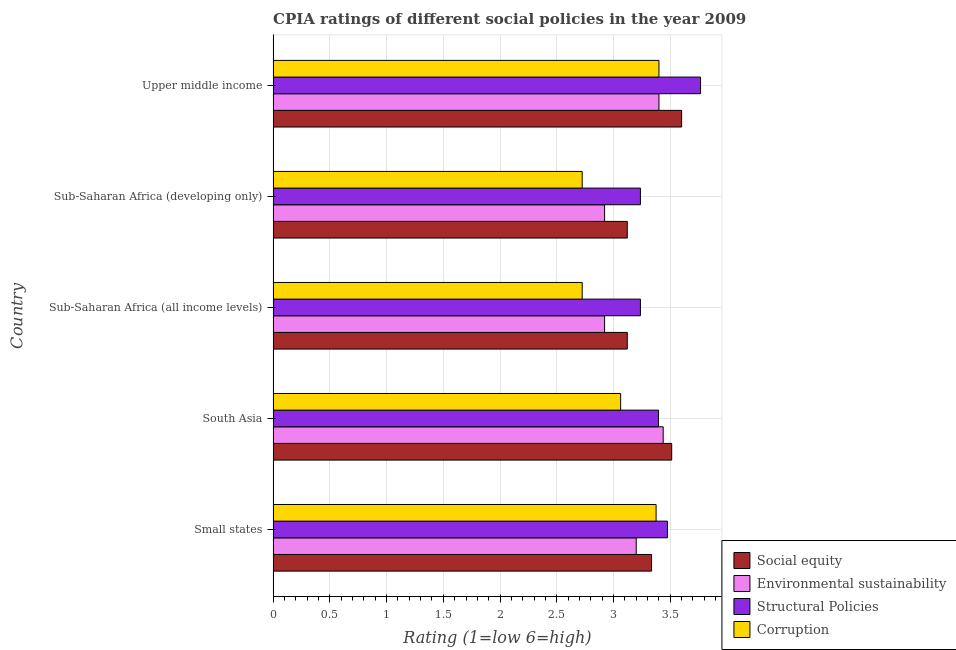How many different coloured bars are there?
Ensure brevity in your answer.  4. What is the label of the 2nd group of bars from the top?
Provide a short and direct response. Sub-Saharan Africa (developing only). In how many cases, is the number of bars for a given country not equal to the number of legend labels?
Provide a succinct answer. 0. Across all countries, what is the maximum cpia rating of social equity?
Offer a very short reply. 3.6. Across all countries, what is the minimum cpia rating of corruption?
Make the answer very short. 2.72. In which country was the cpia rating of social equity maximum?
Ensure brevity in your answer.  Upper middle income. In which country was the cpia rating of corruption minimum?
Your answer should be very brief. Sub-Saharan Africa (all income levels). What is the total cpia rating of structural policies in the graph?
Your response must be concise. 17.11. What is the difference between the cpia rating of structural policies in Small states and that in Upper middle income?
Your answer should be compact. -0.29. What is the difference between the cpia rating of structural policies in South Asia and the cpia rating of environmental sustainability in Upper middle income?
Offer a very short reply. -0. What is the average cpia rating of structural policies per country?
Offer a very short reply. 3.42. In how many countries, is the cpia rating of structural policies greater than 1.7 ?
Make the answer very short. 5. What is the ratio of the cpia rating of structural policies in Small states to that in Sub-Saharan Africa (all income levels)?
Make the answer very short. 1.07. Is the cpia rating of social equity in Sub-Saharan Africa (all income levels) less than that in Sub-Saharan Africa (developing only)?
Provide a short and direct response. No. What is the difference between the highest and the second highest cpia rating of social equity?
Give a very brief answer. 0.09. What is the difference between the highest and the lowest cpia rating of environmental sustainability?
Offer a very short reply. 0.52. In how many countries, is the cpia rating of environmental sustainability greater than the average cpia rating of environmental sustainability taken over all countries?
Your answer should be very brief. 3. What does the 3rd bar from the top in Upper middle income represents?
Your answer should be compact. Environmental sustainability. What does the 2nd bar from the bottom in Small states represents?
Make the answer very short. Environmental sustainability. Is it the case that in every country, the sum of the cpia rating of social equity and cpia rating of environmental sustainability is greater than the cpia rating of structural policies?
Your response must be concise. Yes. How many countries are there in the graph?
Make the answer very short. 5. Does the graph contain grids?
Make the answer very short. Yes. Where does the legend appear in the graph?
Your answer should be very brief. Bottom right. What is the title of the graph?
Offer a very short reply. CPIA ratings of different social policies in the year 2009. Does "Third 20% of population" appear as one of the legend labels in the graph?
Provide a succinct answer. No. What is the label or title of the X-axis?
Make the answer very short. Rating (1=low 6=high). What is the Rating (1=low 6=high) of Social equity in Small states?
Your answer should be compact. 3.33. What is the Rating (1=low 6=high) in Structural Policies in Small states?
Offer a very short reply. 3.48. What is the Rating (1=low 6=high) in Corruption in Small states?
Your answer should be compact. 3.38. What is the Rating (1=low 6=high) of Social equity in South Asia?
Offer a terse response. 3.51. What is the Rating (1=low 6=high) of Environmental sustainability in South Asia?
Provide a short and direct response. 3.44. What is the Rating (1=low 6=high) in Structural Policies in South Asia?
Keep it short and to the point. 3.4. What is the Rating (1=low 6=high) of Corruption in South Asia?
Your answer should be very brief. 3.06. What is the Rating (1=low 6=high) in Social equity in Sub-Saharan Africa (all income levels)?
Provide a short and direct response. 3.12. What is the Rating (1=low 6=high) of Environmental sustainability in Sub-Saharan Africa (all income levels)?
Your answer should be very brief. 2.92. What is the Rating (1=low 6=high) in Structural Policies in Sub-Saharan Africa (all income levels)?
Offer a very short reply. 3.24. What is the Rating (1=low 6=high) of Corruption in Sub-Saharan Africa (all income levels)?
Provide a short and direct response. 2.72. What is the Rating (1=low 6=high) of Social equity in Sub-Saharan Africa (developing only)?
Your answer should be compact. 3.12. What is the Rating (1=low 6=high) of Environmental sustainability in Sub-Saharan Africa (developing only)?
Give a very brief answer. 2.92. What is the Rating (1=low 6=high) in Structural Policies in Sub-Saharan Africa (developing only)?
Give a very brief answer. 3.24. What is the Rating (1=low 6=high) in Corruption in Sub-Saharan Africa (developing only)?
Ensure brevity in your answer.  2.72. What is the Rating (1=low 6=high) in Structural Policies in Upper middle income?
Your answer should be very brief. 3.77. Across all countries, what is the maximum Rating (1=low 6=high) of Environmental sustainability?
Your answer should be very brief. 3.44. Across all countries, what is the maximum Rating (1=low 6=high) in Structural Policies?
Offer a very short reply. 3.77. Across all countries, what is the maximum Rating (1=low 6=high) of Corruption?
Provide a short and direct response. 3.4. Across all countries, what is the minimum Rating (1=low 6=high) of Social equity?
Provide a short and direct response. 3.12. Across all countries, what is the minimum Rating (1=low 6=high) in Environmental sustainability?
Keep it short and to the point. 2.92. Across all countries, what is the minimum Rating (1=low 6=high) in Structural Policies?
Your answer should be very brief. 3.24. Across all countries, what is the minimum Rating (1=low 6=high) of Corruption?
Offer a terse response. 2.72. What is the total Rating (1=low 6=high) of Social equity in the graph?
Offer a very short reply. 16.69. What is the total Rating (1=low 6=high) in Environmental sustainability in the graph?
Keep it short and to the point. 15.88. What is the total Rating (1=low 6=high) of Structural Policies in the graph?
Your response must be concise. 17.11. What is the total Rating (1=low 6=high) in Corruption in the graph?
Offer a very short reply. 15.28. What is the difference between the Rating (1=low 6=high) in Social equity in Small states and that in South Asia?
Offer a very short reply. -0.18. What is the difference between the Rating (1=low 6=high) in Environmental sustainability in Small states and that in South Asia?
Your answer should be compact. -0.24. What is the difference between the Rating (1=low 6=high) in Structural Policies in Small states and that in South Asia?
Offer a very short reply. 0.08. What is the difference between the Rating (1=low 6=high) of Corruption in Small states and that in South Asia?
Make the answer very short. 0.31. What is the difference between the Rating (1=low 6=high) of Social equity in Small states and that in Sub-Saharan Africa (all income levels)?
Your response must be concise. 0.21. What is the difference between the Rating (1=low 6=high) in Environmental sustainability in Small states and that in Sub-Saharan Africa (all income levels)?
Your response must be concise. 0.28. What is the difference between the Rating (1=low 6=high) of Structural Policies in Small states and that in Sub-Saharan Africa (all income levels)?
Provide a short and direct response. 0.24. What is the difference between the Rating (1=low 6=high) of Corruption in Small states and that in Sub-Saharan Africa (all income levels)?
Your answer should be compact. 0.65. What is the difference between the Rating (1=low 6=high) of Social equity in Small states and that in Sub-Saharan Africa (developing only)?
Your answer should be very brief. 0.21. What is the difference between the Rating (1=low 6=high) in Environmental sustainability in Small states and that in Sub-Saharan Africa (developing only)?
Provide a short and direct response. 0.28. What is the difference between the Rating (1=low 6=high) in Structural Policies in Small states and that in Sub-Saharan Africa (developing only)?
Keep it short and to the point. 0.24. What is the difference between the Rating (1=low 6=high) in Corruption in Small states and that in Sub-Saharan Africa (developing only)?
Provide a short and direct response. 0.65. What is the difference between the Rating (1=low 6=high) of Social equity in Small states and that in Upper middle income?
Give a very brief answer. -0.27. What is the difference between the Rating (1=low 6=high) of Structural Policies in Small states and that in Upper middle income?
Provide a short and direct response. -0.29. What is the difference between the Rating (1=low 6=high) of Corruption in Small states and that in Upper middle income?
Your answer should be compact. -0.03. What is the difference between the Rating (1=low 6=high) in Social equity in South Asia and that in Sub-Saharan Africa (all income levels)?
Provide a short and direct response. 0.39. What is the difference between the Rating (1=low 6=high) in Environmental sustainability in South Asia and that in Sub-Saharan Africa (all income levels)?
Provide a succinct answer. 0.52. What is the difference between the Rating (1=low 6=high) of Structural Policies in South Asia and that in Sub-Saharan Africa (all income levels)?
Your answer should be very brief. 0.16. What is the difference between the Rating (1=low 6=high) in Corruption in South Asia and that in Sub-Saharan Africa (all income levels)?
Ensure brevity in your answer.  0.34. What is the difference between the Rating (1=low 6=high) of Social equity in South Asia and that in Sub-Saharan Africa (developing only)?
Offer a terse response. 0.39. What is the difference between the Rating (1=low 6=high) of Environmental sustainability in South Asia and that in Sub-Saharan Africa (developing only)?
Ensure brevity in your answer.  0.52. What is the difference between the Rating (1=low 6=high) of Structural Policies in South Asia and that in Sub-Saharan Africa (developing only)?
Offer a very short reply. 0.16. What is the difference between the Rating (1=low 6=high) of Corruption in South Asia and that in Sub-Saharan Africa (developing only)?
Your answer should be very brief. 0.34. What is the difference between the Rating (1=low 6=high) in Social equity in South Asia and that in Upper middle income?
Your answer should be very brief. -0.09. What is the difference between the Rating (1=low 6=high) of Environmental sustainability in South Asia and that in Upper middle income?
Your answer should be very brief. 0.04. What is the difference between the Rating (1=low 6=high) of Structural Policies in South Asia and that in Upper middle income?
Your answer should be compact. -0.37. What is the difference between the Rating (1=low 6=high) in Corruption in South Asia and that in Upper middle income?
Keep it short and to the point. -0.34. What is the difference between the Rating (1=low 6=high) in Environmental sustainability in Sub-Saharan Africa (all income levels) and that in Sub-Saharan Africa (developing only)?
Provide a short and direct response. 0. What is the difference between the Rating (1=low 6=high) of Structural Policies in Sub-Saharan Africa (all income levels) and that in Sub-Saharan Africa (developing only)?
Provide a succinct answer. 0. What is the difference between the Rating (1=low 6=high) of Social equity in Sub-Saharan Africa (all income levels) and that in Upper middle income?
Make the answer very short. -0.48. What is the difference between the Rating (1=low 6=high) in Environmental sustainability in Sub-Saharan Africa (all income levels) and that in Upper middle income?
Make the answer very short. -0.48. What is the difference between the Rating (1=low 6=high) of Structural Policies in Sub-Saharan Africa (all income levels) and that in Upper middle income?
Offer a terse response. -0.53. What is the difference between the Rating (1=low 6=high) of Corruption in Sub-Saharan Africa (all income levels) and that in Upper middle income?
Offer a very short reply. -0.68. What is the difference between the Rating (1=low 6=high) in Social equity in Sub-Saharan Africa (developing only) and that in Upper middle income?
Make the answer very short. -0.48. What is the difference between the Rating (1=low 6=high) of Environmental sustainability in Sub-Saharan Africa (developing only) and that in Upper middle income?
Your answer should be compact. -0.48. What is the difference between the Rating (1=low 6=high) in Structural Policies in Sub-Saharan Africa (developing only) and that in Upper middle income?
Ensure brevity in your answer.  -0.53. What is the difference between the Rating (1=low 6=high) in Corruption in Sub-Saharan Africa (developing only) and that in Upper middle income?
Keep it short and to the point. -0.68. What is the difference between the Rating (1=low 6=high) in Social equity in Small states and the Rating (1=low 6=high) in Environmental sustainability in South Asia?
Provide a succinct answer. -0.1. What is the difference between the Rating (1=low 6=high) in Social equity in Small states and the Rating (1=low 6=high) in Structural Policies in South Asia?
Offer a terse response. -0.06. What is the difference between the Rating (1=low 6=high) in Social equity in Small states and the Rating (1=low 6=high) in Corruption in South Asia?
Provide a succinct answer. 0.27. What is the difference between the Rating (1=low 6=high) in Environmental sustainability in Small states and the Rating (1=low 6=high) in Structural Policies in South Asia?
Give a very brief answer. -0.2. What is the difference between the Rating (1=low 6=high) in Environmental sustainability in Small states and the Rating (1=low 6=high) in Corruption in South Asia?
Make the answer very short. 0.14. What is the difference between the Rating (1=low 6=high) in Structural Policies in Small states and the Rating (1=low 6=high) in Corruption in South Asia?
Offer a very short reply. 0.41. What is the difference between the Rating (1=low 6=high) in Social equity in Small states and the Rating (1=low 6=high) in Environmental sustainability in Sub-Saharan Africa (all income levels)?
Make the answer very short. 0.41. What is the difference between the Rating (1=low 6=high) in Social equity in Small states and the Rating (1=low 6=high) in Structural Policies in Sub-Saharan Africa (all income levels)?
Offer a terse response. 0.1. What is the difference between the Rating (1=low 6=high) in Social equity in Small states and the Rating (1=low 6=high) in Corruption in Sub-Saharan Africa (all income levels)?
Your answer should be compact. 0.61. What is the difference between the Rating (1=low 6=high) of Environmental sustainability in Small states and the Rating (1=low 6=high) of Structural Policies in Sub-Saharan Africa (all income levels)?
Make the answer very short. -0.04. What is the difference between the Rating (1=low 6=high) in Environmental sustainability in Small states and the Rating (1=low 6=high) in Corruption in Sub-Saharan Africa (all income levels)?
Your answer should be compact. 0.48. What is the difference between the Rating (1=low 6=high) of Structural Policies in Small states and the Rating (1=low 6=high) of Corruption in Sub-Saharan Africa (all income levels)?
Provide a succinct answer. 0.75. What is the difference between the Rating (1=low 6=high) of Social equity in Small states and the Rating (1=low 6=high) of Environmental sustainability in Sub-Saharan Africa (developing only)?
Your answer should be compact. 0.41. What is the difference between the Rating (1=low 6=high) in Social equity in Small states and the Rating (1=low 6=high) in Structural Policies in Sub-Saharan Africa (developing only)?
Ensure brevity in your answer.  0.1. What is the difference between the Rating (1=low 6=high) of Social equity in Small states and the Rating (1=low 6=high) of Corruption in Sub-Saharan Africa (developing only)?
Your answer should be very brief. 0.61. What is the difference between the Rating (1=low 6=high) of Environmental sustainability in Small states and the Rating (1=low 6=high) of Structural Policies in Sub-Saharan Africa (developing only)?
Offer a terse response. -0.04. What is the difference between the Rating (1=low 6=high) of Environmental sustainability in Small states and the Rating (1=low 6=high) of Corruption in Sub-Saharan Africa (developing only)?
Your response must be concise. 0.48. What is the difference between the Rating (1=low 6=high) in Structural Policies in Small states and the Rating (1=low 6=high) in Corruption in Sub-Saharan Africa (developing only)?
Make the answer very short. 0.75. What is the difference between the Rating (1=low 6=high) in Social equity in Small states and the Rating (1=low 6=high) in Environmental sustainability in Upper middle income?
Provide a short and direct response. -0.07. What is the difference between the Rating (1=low 6=high) of Social equity in Small states and the Rating (1=low 6=high) of Structural Policies in Upper middle income?
Your response must be concise. -0.43. What is the difference between the Rating (1=low 6=high) in Social equity in Small states and the Rating (1=low 6=high) in Corruption in Upper middle income?
Offer a very short reply. -0.07. What is the difference between the Rating (1=low 6=high) in Environmental sustainability in Small states and the Rating (1=low 6=high) in Structural Policies in Upper middle income?
Provide a succinct answer. -0.57. What is the difference between the Rating (1=low 6=high) in Environmental sustainability in Small states and the Rating (1=low 6=high) in Corruption in Upper middle income?
Offer a very short reply. -0.2. What is the difference between the Rating (1=low 6=high) of Structural Policies in Small states and the Rating (1=low 6=high) of Corruption in Upper middle income?
Give a very brief answer. 0.07. What is the difference between the Rating (1=low 6=high) in Social equity in South Asia and the Rating (1=low 6=high) in Environmental sustainability in Sub-Saharan Africa (all income levels)?
Ensure brevity in your answer.  0.59. What is the difference between the Rating (1=low 6=high) of Social equity in South Asia and the Rating (1=low 6=high) of Structural Policies in Sub-Saharan Africa (all income levels)?
Your answer should be very brief. 0.28. What is the difference between the Rating (1=low 6=high) in Social equity in South Asia and the Rating (1=low 6=high) in Corruption in Sub-Saharan Africa (all income levels)?
Give a very brief answer. 0.79. What is the difference between the Rating (1=low 6=high) in Environmental sustainability in South Asia and the Rating (1=low 6=high) in Structural Policies in Sub-Saharan Africa (all income levels)?
Keep it short and to the point. 0.2. What is the difference between the Rating (1=low 6=high) in Environmental sustainability in South Asia and the Rating (1=low 6=high) in Corruption in Sub-Saharan Africa (all income levels)?
Your answer should be compact. 0.71. What is the difference between the Rating (1=low 6=high) of Structural Policies in South Asia and the Rating (1=low 6=high) of Corruption in Sub-Saharan Africa (all income levels)?
Ensure brevity in your answer.  0.67. What is the difference between the Rating (1=low 6=high) of Social equity in South Asia and the Rating (1=low 6=high) of Environmental sustainability in Sub-Saharan Africa (developing only)?
Provide a short and direct response. 0.59. What is the difference between the Rating (1=low 6=high) in Social equity in South Asia and the Rating (1=low 6=high) in Structural Policies in Sub-Saharan Africa (developing only)?
Provide a short and direct response. 0.28. What is the difference between the Rating (1=low 6=high) of Social equity in South Asia and the Rating (1=low 6=high) of Corruption in Sub-Saharan Africa (developing only)?
Provide a short and direct response. 0.79. What is the difference between the Rating (1=low 6=high) in Environmental sustainability in South Asia and the Rating (1=low 6=high) in Structural Policies in Sub-Saharan Africa (developing only)?
Your answer should be compact. 0.2. What is the difference between the Rating (1=low 6=high) in Environmental sustainability in South Asia and the Rating (1=low 6=high) in Corruption in Sub-Saharan Africa (developing only)?
Give a very brief answer. 0.71. What is the difference between the Rating (1=low 6=high) of Structural Policies in South Asia and the Rating (1=low 6=high) of Corruption in Sub-Saharan Africa (developing only)?
Give a very brief answer. 0.67. What is the difference between the Rating (1=low 6=high) of Social equity in South Asia and the Rating (1=low 6=high) of Environmental sustainability in Upper middle income?
Keep it short and to the point. 0.11. What is the difference between the Rating (1=low 6=high) in Social equity in South Asia and the Rating (1=low 6=high) in Structural Policies in Upper middle income?
Your answer should be very brief. -0.25. What is the difference between the Rating (1=low 6=high) of Social equity in South Asia and the Rating (1=low 6=high) of Corruption in Upper middle income?
Give a very brief answer. 0.11. What is the difference between the Rating (1=low 6=high) of Environmental sustainability in South Asia and the Rating (1=low 6=high) of Structural Policies in Upper middle income?
Keep it short and to the point. -0.33. What is the difference between the Rating (1=low 6=high) of Environmental sustainability in South Asia and the Rating (1=low 6=high) of Corruption in Upper middle income?
Ensure brevity in your answer.  0.04. What is the difference between the Rating (1=low 6=high) of Structural Policies in South Asia and the Rating (1=low 6=high) of Corruption in Upper middle income?
Keep it short and to the point. -0. What is the difference between the Rating (1=low 6=high) of Social equity in Sub-Saharan Africa (all income levels) and the Rating (1=low 6=high) of Structural Policies in Sub-Saharan Africa (developing only)?
Your response must be concise. -0.12. What is the difference between the Rating (1=low 6=high) of Social equity in Sub-Saharan Africa (all income levels) and the Rating (1=low 6=high) of Corruption in Sub-Saharan Africa (developing only)?
Give a very brief answer. 0.4. What is the difference between the Rating (1=low 6=high) of Environmental sustainability in Sub-Saharan Africa (all income levels) and the Rating (1=low 6=high) of Structural Policies in Sub-Saharan Africa (developing only)?
Offer a very short reply. -0.32. What is the difference between the Rating (1=low 6=high) in Environmental sustainability in Sub-Saharan Africa (all income levels) and the Rating (1=low 6=high) in Corruption in Sub-Saharan Africa (developing only)?
Make the answer very short. 0.2. What is the difference between the Rating (1=low 6=high) in Structural Policies in Sub-Saharan Africa (all income levels) and the Rating (1=low 6=high) in Corruption in Sub-Saharan Africa (developing only)?
Provide a short and direct response. 0.51. What is the difference between the Rating (1=low 6=high) in Social equity in Sub-Saharan Africa (all income levels) and the Rating (1=low 6=high) in Environmental sustainability in Upper middle income?
Provide a short and direct response. -0.28. What is the difference between the Rating (1=low 6=high) in Social equity in Sub-Saharan Africa (all income levels) and the Rating (1=low 6=high) in Structural Policies in Upper middle income?
Give a very brief answer. -0.65. What is the difference between the Rating (1=low 6=high) in Social equity in Sub-Saharan Africa (all income levels) and the Rating (1=low 6=high) in Corruption in Upper middle income?
Your answer should be compact. -0.28. What is the difference between the Rating (1=low 6=high) of Environmental sustainability in Sub-Saharan Africa (all income levels) and the Rating (1=low 6=high) of Structural Policies in Upper middle income?
Your answer should be very brief. -0.85. What is the difference between the Rating (1=low 6=high) of Environmental sustainability in Sub-Saharan Africa (all income levels) and the Rating (1=low 6=high) of Corruption in Upper middle income?
Ensure brevity in your answer.  -0.48. What is the difference between the Rating (1=low 6=high) in Structural Policies in Sub-Saharan Africa (all income levels) and the Rating (1=low 6=high) in Corruption in Upper middle income?
Your answer should be compact. -0.16. What is the difference between the Rating (1=low 6=high) of Social equity in Sub-Saharan Africa (developing only) and the Rating (1=low 6=high) of Environmental sustainability in Upper middle income?
Make the answer very short. -0.28. What is the difference between the Rating (1=low 6=high) in Social equity in Sub-Saharan Africa (developing only) and the Rating (1=low 6=high) in Structural Policies in Upper middle income?
Your answer should be compact. -0.65. What is the difference between the Rating (1=low 6=high) of Social equity in Sub-Saharan Africa (developing only) and the Rating (1=low 6=high) of Corruption in Upper middle income?
Provide a succinct answer. -0.28. What is the difference between the Rating (1=low 6=high) in Environmental sustainability in Sub-Saharan Africa (developing only) and the Rating (1=low 6=high) in Structural Policies in Upper middle income?
Make the answer very short. -0.85. What is the difference between the Rating (1=low 6=high) of Environmental sustainability in Sub-Saharan Africa (developing only) and the Rating (1=low 6=high) of Corruption in Upper middle income?
Offer a terse response. -0.48. What is the difference between the Rating (1=low 6=high) of Structural Policies in Sub-Saharan Africa (developing only) and the Rating (1=low 6=high) of Corruption in Upper middle income?
Give a very brief answer. -0.16. What is the average Rating (1=low 6=high) in Social equity per country?
Your answer should be compact. 3.34. What is the average Rating (1=low 6=high) in Environmental sustainability per country?
Provide a succinct answer. 3.18. What is the average Rating (1=low 6=high) in Structural Policies per country?
Provide a short and direct response. 3.42. What is the average Rating (1=low 6=high) of Corruption per country?
Provide a short and direct response. 3.06. What is the difference between the Rating (1=low 6=high) in Social equity and Rating (1=low 6=high) in Environmental sustainability in Small states?
Give a very brief answer. 0.14. What is the difference between the Rating (1=low 6=high) in Social equity and Rating (1=low 6=high) in Structural Policies in Small states?
Keep it short and to the point. -0.14. What is the difference between the Rating (1=low 6=high) of Social equity and Rating (1=low 6=high) of Corruption in Small states?
Provide a succinct answer. -0.04. What is the difference between the Rating (1=low 6=high) of Environmental sustainability and Rating (1=low 6=high) of Structural Policies in Small states?
Make the answer very short. -0.28. What is the difference between the Rating (1=low 6=high) in Environmental sustainability and Rating (1=low 6=high) in Corruption in Small states?
Ensure brevity in your answer.  -0.17. What is the difference between the Rating (1=low 6=high) of Structural Policies and Rating (1=low 6=high) of Corruption in Small states?
Provide a short and direct response. 0.1. What is the difference between the Rating (1=low 6=high) in Social equity and Rating (1=low 6=high) in Environmental sustainability in South Asia?
Your answer should be compact. 0.07. What is the difference between the Rating (1=low 6=high) in Social equity and Rating (1=low 6=high) in Structural Policies in South Asia?
Your answer should be compact. 0.12. What is the difference between the Rating (1=low 6=high) in Social equity and Rating (1=low 6=high) in Corruption in South Asia?
Your response must be concise. 0.45. What is the difference between the Rating (1=low 6=high) of Environmental sustainability and Rating (1=low 6=high) of Structural Policies in South Asia?
Give a very brief answer. 0.04. What is the difference between the Rating (1=low 6=high) in Environmental sustainability and Rating (1=low 6=high) in Corruption in South Asia?
Offer a very short reply. 0.38. What is the difference between the Rating (1=low 6=high) in Social equity and Rating (1=low 6=high) in Structural Policies in Sub-Saharan Africa (all income levels)?
Provide a succinct answer. -0.12. What is the difference between the Rating (1=low 6=high) of Social equity and Rating (1=low 6=high) of Corruption in Sub-Saharan Africa (all income levels)?
Provide a succinct answer. 0.4. What is the difference between the Rating (1=low 6=high) in Environmental sustainability and Rating (1=low 6=high) in Structural Policies in Sub-Saharan Africa (all income levels)?
Your response must be concise. -0.32. What is the difference between the Rating (1=low 6=high) in Environmental sustainability and Rating (1=low 6=high) in Corruption in Sub-Saharan Africa (all income levels)?
Offer a terse response. 0.2. What is the difference between the Rating (1=low 6=high) in Structural Policies and Rating (1=low 6=high) in Corruption in Sub-Saharan Africa (all income levels)?
Provide a short and direct response. 0.51. What is the difference between the Rating (1=low 6=high) in Social equity and Rating (1=low 6=high) in Structural Policies in Sub-Saharan Africa (developing only)?
Your answer should be compact. -0.12. What is the difference between the Rating (1=low 6=high) in Social equity and Rating (1=low 6=high) in Corruption in Sub-Saharan Africa (developing only)?
Your answer should be compact. 0.4. What is the difference between the Rating (1=low 6=high) of Environmental sustainability and Rating (1=low 6=high) of Structural Policies in Sub-Saharan Africa (developing only)?
Your answer should be very brief. -0.32. What is the difference between the Rating (1=low 6=high) of Environmental sustainability and Rating (1=low 6=high) of Corruption in Sub-Saharan Africa (developing only)?
Keep it short and to the point. 0.2. What is the difference between the Rating (1=low 6=high) in Structural Policies and Rating (1=low 6=high) in Corruption in Sub-Saharan Africa (developing only)?
Provide a short and direct response. 0.51. What is the difference between the Rating (1=low 6=high) of Social equity and Rating (1=low 6=high) of Environmental sustainability in Upper middle income?
Your answer should be very brief. 0.2. What is the difference between the Rating (1=low 6=high) of Environmental sustainability and Rating (1=low 6=high) of Structural Policies in Upper middle income?
Your answer should be very brief. -0.37. What is the difference between the Rating (1=low 6=high) of Structural Policies and Rating (1=low 6=high) of Corruption in Upper middle income?
Your answer should be compact. 0.37. What is the ratio of the Rating (1=low 6=high) of Social equity in Small states to that in South Asia?
Your answer should be very brief. 0.95. What is the ratio of the Rating (1=low 6=high) of Environmental sustainability in Small states to that in South Asia?
Offer a very short reply. 0.93. What is the ratio of the Rating (1=low 6=high) of Structural Policies in Small states to that in South Asia?
Keep it short and to the point. 1.02. What is the ratio of the Rating (1=low 6=high) in Corruption in Small states to that in South Asia?
Give a very brief answer. 1.1. What is the ratio of the Rating (1=low 6=high) in Social equity in Small states to that in Sub-Saharan Africa (all income levels)?
Offer a very short reply. 1.07. What is the ratio of the Rating (1=low 6=high) in Environmental sustainability in Small states to that in Sub-Saharan Africa (all income levels)?
Keep it short and to the point. 1.1. What is the ratio of the Rating (1=low 6=high) in Structural Policies in Small states to that in Sub-Saharan Africa (all income levels)?
Offer a very short reply. 1.07. What is the ratio of the Rating (1=low 6=high) of Corruption in Small states to that in Sub-Saharan Africa (all income levels)?
Keep it short and to the point. 1.24. What is the ratio of the Rating (1=low 6=high) in Social equity in Small states to that in Sub-Saharan Africa (developing only)?
Offer a very short reply. 1.07. What is the ratio of the Rating (1=low 6=high) of Environmental sustainability in Small states to that in Sub-Saharan Africa (developing only)?
Offer a terse response. 1.1. What is the ratio of the Rating (1=low 6=high) of Structural Policies in Small states to that in Sub-Saharan Africa (developing only)?
Give a very brief answer. 1.07. What is the ratio of the Rating (1=low 6=high) of Corruption in Small states to that in Sub-Saharan Africa (developing only)?
Your response must be concise. 1.24. What is the ratio of the Rating (1=low 6=high) of Social equity in Small states to that in Upper middle income?
Your response must be concise. 0.93. What is the ratio of the Rating (1=low 6=high) in Structural Policies in Small states to that in Upper middle income?
Your answer should be compact. 0.92. What is the ratio of the Rating (1=low 6=high) of Social equity in South Asia to that in Sub-Saharan Africa (all income levels)?
Your answer should be compact. 1.13. What is the ratio of the Rating (1=low 6=high) in Environmental sustainability in South Asia to that in Sub-Saharan Africa (all income levels)?
Offer a very short reply. 1.18. What is the ratio of the Rating (1=low 6=high) in Structural Policies in South Asia to that in Sub-Saharan Africa (all income levels)?
Provide a succinct answer. 1.05. What is the ratio of the Rating (1=low 6=high) in Corruption in South Asia to that in Sub-Saharan Africa (all income levels)?
Provide a short and direct response. 1.12. What is the ratio of the Rating (1=low 6=high) in Social equity in South Asia to that in Sub-Saharan Africa (developing only)?
Provide a short and direct response. 1.13. What is the ratio of the Rating (1=low 6=high) in Environmental sustainability in South Asia to that in Sub-Saharan Africa (developing only)?
Your answer should be compact. 1.18. What is the ratio of the Rating (1=low 6=high) in Structural Policies in South Asia to that in Sub-Saharan Africa (developing only)?
Provide a succinct answer. 1.05. What is the ratio of the Rating (1=low 6=high) of Corruption in South Asia to that in Sub-Saharan Africa (developing only)?
Provide a succinct answer. 1.12. What is the ratio of the Rating (1=low 6=high) of Social equity in South Asia to that in Upper middle income?
Your answer should be very brief. 0.98. What is the ratio of the Rating (1=low 6=high) of Structural Policies in South Asia to that in Upper middle income?
Ensure brevity in your answer.  0.9. What is the ratio of the Rating (1=low 6=high) of Corruption in South Asia to that in Upper middle income?
Keep it short and to the point. 0.9. What is the ratio of the Rating (1=low 6=high) in Social equity in Sub-Saharan Africa (all income levels) to that in Sub-Saharan Africa (developing only)?
Your response must be concise. 1. What is the ratio of the Rating (1=low 6=high) of Corruption in Sub-Saharan Africa (all income levels) to that in Sub-Saharan Africa (developing only)?
Ensure brevity in your answer.  1. What is the ratio of the Rating (1=low 6=high) in Social equity in Sub-Saharan Africa (all income levels) to that in Upper middle income?
Provide a succinct answer. 0.87. What is the ratio of the Rating (1=low 6=high) in Environmental sustainability in Sub-Saharan Africa (all income levels) to that in Upper middle income?
Provide a short and direct response. 0.86. What is the ratio of the Rating (1=low 6=high) in Structural Policies in Sub-Saharan Africa (all income levels) to that in Upper middle income?
Provide a succinct answer. 0.86. What is the ratio of the Rating (1=low 6=high) in Corruption in Sub-Saharan Africa (all income levels) to that in Upper middle income?
Give a very brief answer. 0.8. What is the ratio of the Rating (1=low 6=high) of Social equity in Sub-Saharan Africa (developing only) to that in Upper middle income?
Ensure brevity in your answer.  0.87. What is the ratio of the Rating (1=low 6=high) in Environmental sustainability in Sub-Saharan Africa (developing only) to that in Upper middle income?
Keep it short and to the point. 0.86. What is the ratio of the Rating (1=low 6=high) of Structural Policies in Sub-Saharan Africa (developing only) to that in Upper middle income?
Your answer should be compact. 0.86. What is the ratio of the Rating (1=low 6=high) of Corruption in Sub-Saharan Africa (developing only) to that in Upper middle income?
Keep it short and to the point. 0.8. What is the difference between the highest and the second highest Rating (1=low 6=high) of Social equity?
Ensure brevity in your answer.  0.09. What is the difference between the highest and the second highest Rating (1=low 6=high) of Environmental sustainability?
Offer a very short reply. 0.04. What is the difference between the highest and the second highest Rating (1=low 6=high) in Structural Policies?
Provide a short and direct response. 0.29. What is the difference between the highest and the second highest Rating (1=low 6=high) in Corruption?
Your response must be concise. 0.03. What is the difference between the highest and the lowest Rating (1=low 6=high) of Social equity?
Your answer should be very brief. 0.48. What is the difference between the highest and the lowest Rating (1=low 6=high) of Environmental sustainability?
Provide a succinct answer. 0.52. What is the difference between the highest and the lowest Rating (1=low 6=high) of Structural Policies?
Offer a very short reply. 0.53. What is the difference between the highest and the lowest Rating (1=low 6=high) of Corruption?
Make the answer very short. 0.68. 